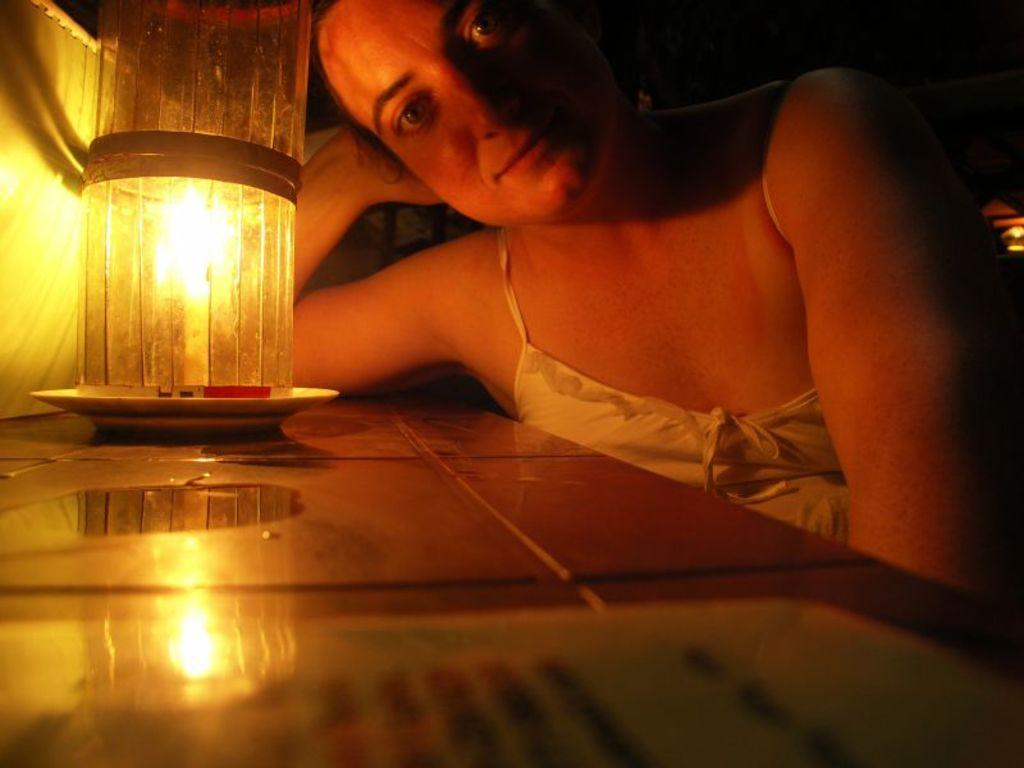What is the main subject of the image? There is a person in the image. Can you describe the person's attire? The person is wearing a white dress. What object can be seen on the table in the image? There is a candle in a plate on the table. What type of stem can be seen growing from the lettuce in the image? There is no lettuce or stem present in the image. Can you describe the goat's behavior in the image? There is no goat present in the image. 